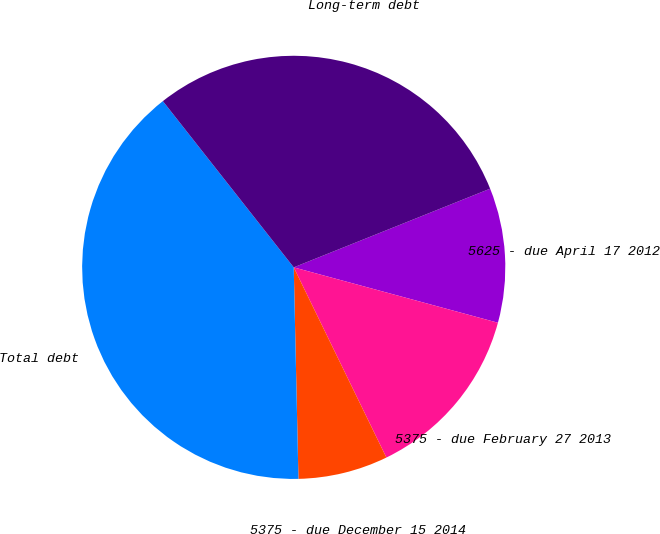Convert chart to OTSL. <chart><loc_0><loc_0><loc_500><loc_500><pie_chart><fcel>5625 - due April 17 2012<fcel>5375 - due February 27 2013<fcel>5375 - due December 15 2014<fcel>Total debt<fcel>Long-term debt<nl><fcel>10.28%<fcel>13.57%<fcel>6.86%<fcel>39.74%<fcel>29.55%<nl></chart> 